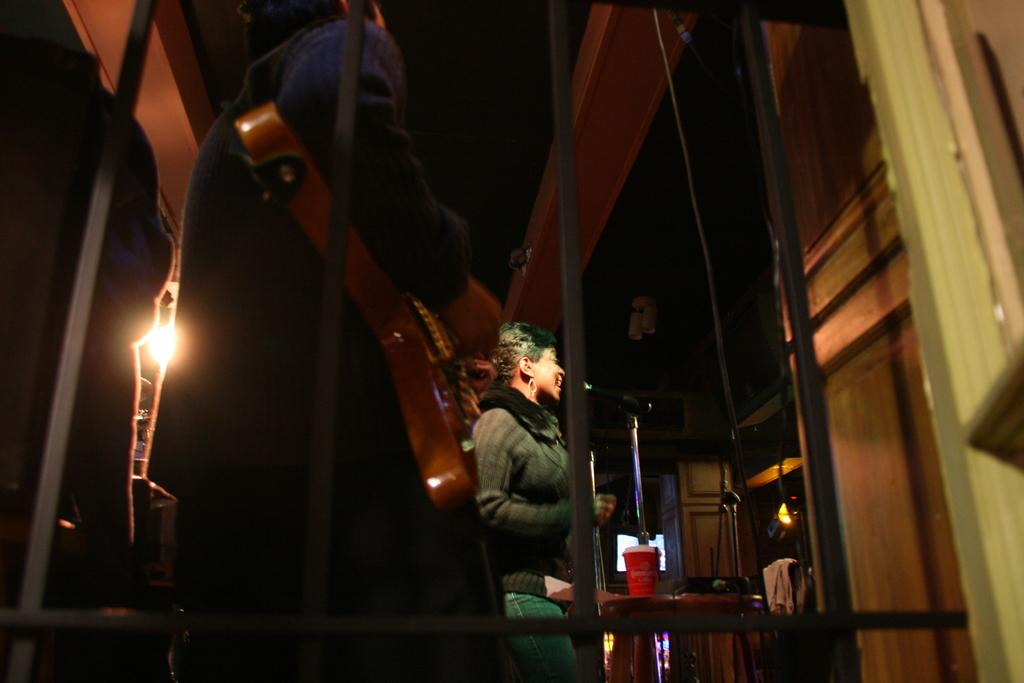What is the main subject of the image? There is a woman standing in the image. What can be seen in the background of the image? There is a wall, a door, and shelves in the image. What is the source of light in the image? There is a light in the image. How would you describe the lighting in the image? The image is described as being a little dark. What type of cakes are listed on the shelves in the image? There are no cakes or lists present in the image; it only features a woman, a wall, a door, shelves, and a light. 